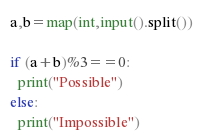<code> <loc_0><loc_0><loc_500><loc_500><_Python_>a,b=map(int,input().split())

if (a+b)%3==0:
  print("Possible")
else:
  print("Impossible")</code> 